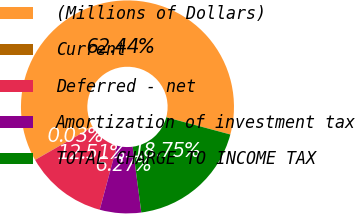Convert chart. <chart><loc_0><loc_0><loc_500><loc_500><pie_chart><fcel>(Millions of Dollars)<fcel>Current<fcel>Deferred - net<fcel>Amortization of investment tax<fcel>TOTAL CHARGE TO INCOME TAX<nl><fcel>62.43%<fcel>0.03%<fcel>12.51%<fcel>6.27%<fcel>18.75%<nl></chart> 